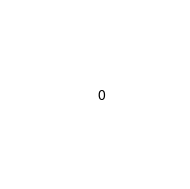<code> <loc_0><loc_0><loc_500><loc_500><_SQL_>0
</code> 